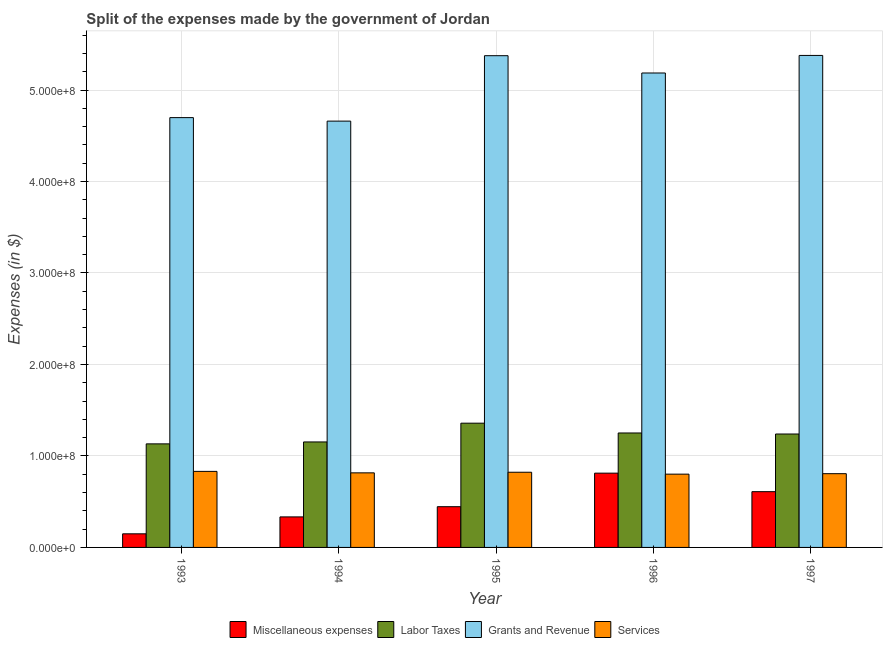Are the number of bars per tick equal to the number of legend labels?
Your answer should be very brief. Yes. What is the label of the 1st group of bars from the left?
Ensure brevity in your answer.  1993. What is the amount spent on labor taxes in 1995?
Make the answer very short. 1.36e+08. Across all years, what is the maximum amount spent on services?
Offer a very short reply. 8.31e+07. Across all years, what is the minimum amount spent on services?
Make the answer very short. 8.01e+07. In which year was the amount spent on services maximum?
Provide a short and direct response. 1993. In which year was the amount spent on miscellaneous expenses minimum?
Provide a succinct answer. 1993. What is the total amount spent on miscellaneous expenses in the graph?
Offer a terse response. 2.35e+08. What is the difference between the amount spent on miscellaneous expenses in 1995 and that in 1997?
Make the answer very short. -1.64e+07. What is the difference between the amount spent on labor taxes in 1997 and the amount spent on services in 1996?
Offer a very short reply. -1.13e+06. What is the average amount spent on grants and revenue per year?
Provide a short and direct response. 5.06e+08. In the year 1997, what is the difference between the amount spent on services and amount spent on miscellaneous expenses?
Offer a very short reply. 0. In how many years, is the amount spent on services greater than 440000000 $?
Offer a terse response. 0. What is the ratio of the amount spent on miscellaneous expenses in 1993 to that in 1995?
Your response must be concise. 0.33. What is the difference between the highest and the second highest amount spent on miscellaneous expenses?
Offer a very short reply. 2.02e+07. What is the difference between the highest and the lowest amount spent on services?
Keep it short and to the point. 3.02e+06. Is the sum of the amount spent on miscellaneous expenses in 1994 and 1997 greater than the maximum amount spent on grants and revenue across all years?
Your answer should be very brief. Yes. Is it the case that in every year, the sum of the amount spent on labor taxes and amount spent on grants and revenue is greater than the sum of amount spent on services and amount spent on miscellaneous expenses?
Ensure brevity in your answer.  No. What does the 2nd bar from the left in 1997 represents?
Make the answer very short. Labor Taxes. What does the 1st bar from the right in 1994 represents?
Offer a terse response. Services. Are the values on the major ticks of Y-axis written in scientific E-notation?
Your answer should be compact. Yes. Does the graph contain any zero values?
Ensure brevity in your answer.  No. Does the graph contain grids?
Offer a terse response. Yes. What is the title of the graph?
Give a very brief answer. Split of the expenses made by the government of Jordan. What is the label or title of the X-axis?
Provide a short and direct response. Year. What is the label or title of the Y-axis?
Your answer should be very brief. Expenses (in $). What is the Expenses (in $) of Miscellaneous expenses in 1993?
Make the answer very short. 1.49e+07. What is the Expenses (in $) of Labor Taxes in 1993?
Your answer should be compact. 1.13e+08. What is the Expenses (in $) in Grants and Revenue in 1993?
Offer a terse response. 4.70e+08. What is the Expenses (in $) of Services in 1993?
Your answer should be compact. 8.31e+07. What is the Expenses (in $) in Miscellaneous expenses in 1994?
Provide a succinct answer. 3.34e+07. What is the Expenses (in $) in Labor Taxes in 1994?
Your answer should be compact. 1.15e+08. What is the Expenses (in $) in Grants and Revenue in 1994?
Provide a short and direct response. 4.66e+08. What is the Expenses (in $) of Services in 1994?
Make the answer very short. 8.15e+07. What is the Expenses (in $) in Miscellaneous expenses in 1995?
Your answer should be very brief. 4.45e+07. What is the Expenses (in $) of Labor Taxes in 1995?
Provide a succinct answer. 1.36e+08. What is the Expenses (in $) of Grants and Revenue in 1995?
Make the answer very short. 5.38e+08. What is the Expenses (in $) of Services in 1995?
Your response must be concise. 8.22e+07. What is the Expenses (in $) in Miscellaneous expenses in 1996?
Keep it short and to the point. 8.12e+07. What is the Expenses (in $) of Labor Taxes in 1996?
Your answer should be compact. 1.25e+08. What is the Expenses (in $) of Grants and Revenue in 1996?
Your answer should be compact. 5.19e+08. What is the Expenses (in $) of Services in 1996?
Make the answer very short. 8.01e+07. What is the Expenses (in $) of Miscellaneous expenses in 1997?
Give a very brief answer. 6.10e+07. What is the Expenses (in $) in Labor Taxes in 1997?
Your answer should be very brief. 1.24e+08. What is the Expenses (in $) in Grants and Revenue in 1997?
Your answer should be very brief. 5.38e+08. What is the Expenses (in $) of Services in 1997?
Offer a terse response. 8.06e+07. Across all years, what is the maximum Expenses (in $) of Miscellaneous expenses?
Offer a very short reply. 8.12e+07. Across all years, what is the maximum Expenses (in $) of Labor Taxes?
Offer a very short reply. 1.36e+08. Across all years, what is the maximum Expenses (in $) in Grants and Revenue?
Your answer should be very brief. 5.38e+08. Across all years, what is the maximum Expenses (in $) in Services?
Your answer should be very brief. 8.31e+07. Across all years, what is the minimum Expenses (in $) of Miscellaneous expenses?
Offer a very short reply. 1.49e+07. Across all years, what is the minimum Expenses (in $) in Labor Taxes?
Make the answer very short. 1.13e+08. Across all years, what is the minimum Expenses (in $) in Grants and Revenue?
Your response must be concise. 4.66e+08. Across all years, what is the minimum Expenses (in $) in Services?
Your answer should be very brief. 8.01e+07. What is the total Expenses (in $) in Miscellaneous expenses in the graph?
Your response must be concise. 2.35e+08. What is the total Expenses (in $) in Labor Taxes in the graph?
Provide a succinct answer. 6.13e+08. What is the total Expenses (in $) of Grants and Revenue in the graph?
Offer a very short reply. 2.53e+09. What is the total Expenses (in $) of Services in the graph?
Offer a terse response. 4.08e+08. What is the difference between the Expenses (in $) of Miscellaneous expenses in 1993 and that in 1994?
Keep it short and to the point. -1.85e+07. What is the difference between the Expenses (in $) of Labor Taxes in 1993 and that in 1994?
Offer a very short reply. -2.11e+06. What is the difference between the Expenses (in $) in Grants and Revenue in 1993 and that in 1994?
Keep it short and to the point. 3.83e+06. What is the difference between the Expenses (in $) of Services in 1993 and that in 1994?
Provide a short and direct response. 1.60e+06. What is the difference between the Expenses (in $) of Miscellaneous expenses in 1993 and that in 1995?
Offer a terse response. -2.96e+07. What is the difference between the Expenses (in $) of Labor Taxes in 1993 and that in 1995?
Give a very brief answer. -2.26e+07. What is the difference between the Expenses (in $) in Grants and Revenue in 1993 and that in 1995?
Your answer should be very brief. -6.77e+07. What is the difference between the Expenses (in $) of Services in 1993 and that in 1995?
Keep it short and to the point. 9.30e+05. What is the difference between the Expenses (in $) in Miscellaneous expenses in 1993 and that in 1996?
Keep it short and to the point. -6.63e+07. What is the difference between the Expenses (in $) of Labor Taxes in 1993 and that in 1996?
Provide a short and direct response. -1.19e+07. What is the difference between the Expenses (in $) of Grants and Revenue in 1993 and that in 1996?
Your answer should be compact. -4.88e+07. What is the difference between the Expenses (in $) in Services in 1993 and that in 1996?
Your response must be concise. 3.02e+06. What is the difference between the Expenses (in $) of Miscellaneous expenses in 1993 and that in 1997?
Your answer should be very brief. -4.61e+07. What is the difference between the Expenses (in $) in Labor Taxes in 1993 and that in 1997?
Provide a succinct answer. -1.08e+07. What is the difference between the Expenses (in $) in Grants and Revenue in 1993 and that in 1997?
Provide a succinct answer. -6.80e+07. What is the difference between the Expenses (in $) of Services in 1993 and that in 1997?
Your answer should be compact. 2.50e+06. What is the difference between the Expenses (in $) of Miscellaneous expenses in 1994 and that in 1995?
Your answer should be very brief. -1.12e+07. What is the difference between the Expenses (in $) in Labor Taxes in 1994 and that in 1995?
Offer a terse response. -2.05e+07. What is the difference between the Expenses (in $) of Grants and Revenue in 1994 and that in 1995?
Your answer should be very brief. -7.15e+07. What is the difference between the Expenses (in $) in Services in 1994 and that in 1995?
Ensure brevity in your answer.  -6.70e+05. What is the difference between the Expenses (in $) of Miscellaneous expenses in 1994 and that in 1996?
Offer a terse response. -4.78e+07. What is the difference between the Expenses (in $) in Labor Taxes in 1994 and that in 1996?
Provide a short and direct response. -9.80e+06. What is the difference between the Expenses (in $) in Grants and Revenue in 1994 and that in 1996?
Provide a short and direct response. -5.26e+07. What is the difference between the Expenses (in $) in Services in 1994 and that in 1996?
Offer a terse response. 1.42e+06. What is the difference between the Expenses (in $) in Miscellaneous expenses in 1994 and that in 1997?
Your answer should be compact. -2.76e+07. What is the difference between the Expenses (in $) in Labor Taxes in 1994 and that in 1997?
Your answer should be very brief. -8.67e+06. What is the difference between the Expenses (in $) of Grants and Revenue in 1994 and that in 1997?
Provide a short and direct response. -7.18e+07. What is the difference between the Expenses (in $) in Miscellaneous expenses in 1995 and that in 1996?
Provide a succinct answer. -3.67e+07. What is the difference between the Expenses (in $) of Labor Taxes in 1995 and that in 1996?
Your answer should be very brief. 1.07e+07. What is the difference between the Expenses (in $) in Grants and Revenue in 1995 and that in 1996?
Provide a short and direct response. 1.89e+07. What is the difference between the Expenses (in $) in Services in 1995 and that in 1996?
Ensure brevity in your answer.  2.09e+06. What is the difference between the Expenses (in $) of Miscellaneous expenses in 1995 and that in 1997?
Your response must be concise. -1.64e+07. What is the difference between the Expenses (in $) of Labor Taxes in 1995 and that in 1997?
Your answer should be compact. 1.18e+07. What is the difference between the Expenses (in $) of Services in 1995 and that in 1997?
Ensure brevity in your answer.  1.57e+06. What is the difference between the Expenses (in $) of Miscellaneous expenses in 1996 and that in 1997?
Your response must be concise. 2.02e+07. What is the difference between the Expenses (in $) in Labor Taxes in 1996 and that in 1997?
Keep it short and to the point. 1.13e+06. What is the difference between the Expenses (in $) in Grants and Revenue in 1996 and that in 1997?
Your response must be concise. -1.92e+07. What is the difference between the Expenses (in $) of Services in 1996 and that in 1997?
Offer a terse response. -5.20e+05. What is the difference between the Expenses (in $) in Miscellaneous expenses in 1993 and the Expenses (in $) in Labor Taxes in 1994?
Ensure brevity in your answer.  -1.00e+08. What is the difference between the Expenses (in $) of Miscellaneous expenses in 1993 and the Expenses (in $) of Grants and Revenue in 1994?
Provide a short and direct response. -4.51e+08. What is the difference between the Expenses (in $) in Miscellaneous expenses in 1993 and the Expenses (in $) in Services in 1994?
Offer a terse response. -6.66e+07. What is the difference between the Expenses (in $) in Labor Taxes in 1993 and the Expenses (in $) in Grants and Revenue in 1994?
Provide a succinct answer. -3.53e+08. What is the difference between the Expenses (in $) of Labor Taxes in 1993 and the Expenses (in $) of Services in 1994?
Your response must be concise. 3.17e+07. What is the difference between the Expenses (in $) in Grants and Revenue in 1993 and the Expenses (in $) in Services in 1994?
Provide a succinct answer. 3.88e+08. What is the difference between the Expenses (in $) of Miscellaneous expenses in 1993 and the Expenses (in $) of Labor Taxes in 1995?
Give a very brief answer. -1.21e+08. What is the difference between the Expenses (in $) of Miscellaneous expenses in 1993 and the Expenses (in $) of Grants and Revenue in 1995?
Offer a terse response. -5.23e+08. What is the difference between the Expenses (in $) of Miscellaneous expenses in 1993 and the Expenses (in $) of Services in 1995?
Give a very brief answer. -6.73e+07. What is the difference between the Expenses (in $) of Labor Taxes in 1993 and the Expenses (in $) of Grants and Revenue in 1995?
Offer a very short reply. -4.24e+08. What is the difference between the Expenses (in $) in Labor Taxes in 1993 and the Expenses (in $) in Services in 1995?
Your response must be concise. 3.10e+07. What is the difference between the Expenses (in $) in Grants and Revenue in 1993 and the Expenses (in $) in Services in 1995?
Provide a short and direct response. 3.88e+08. What is the difference between the Expenses (in $) in Miscellaneous expenses in 1993 and the Expenses (in $) in Labor Taxes in 1996?
Keep it short and to the point. -1.10e+08. What is the difference between the Expenses (in $) in Miscellaneous expenses in 1993 and the Expenses (in $) in Grants and Revenue in 1996?
Provide a succinct answer. -5.04e+08. What is the difference between the Expenses (in $) in Miscellaneous expenses in 1993 and the Expenses (in $) in Services in 1996?
Your response must be concise. -6.52e+07. What is the difference between the Expenses (in $) of Labor Taxes in 1993 and the Expenses (in $) of Grants and Revenue in 1996?
Give a very brief answer. -4.05e+08. What is the difference between the Expenses (in $) in Labor Taxes in 1993 and the Expenses (in $) in Services in 1996?
Provide a succinct answer. 3.31e+07. What is the difference between the Expenses (in $) in Grants and Revenue in 1993 and the Expenses (in $) in Services in 1996?
Provide a short and direct response. 3.90e+08. What is the difference between the Expenses (in $) in Miscellaneous expenses in 1993 and the Expenses (in $) in Labor Taxes in 1997?
Offer a terse response. -1.09e+08. What is the difference between the Expenses (in $) of Miscellaneous expenses in 1993 and the Expenses (in $) of Grants and Revenue in 1997?
Provide a short and direct response. -5.23e+08. What is the difference between the Expenses (in $) of Miscellaneous expenses in 1993 and the Expenses (in $) of Services in 1997?
Give a very brief answer. -6.58e+07. What is the difference between the Expenses (in $) in Labor Taxes in 1993 and the Expenses (in $) in Grants and Revenue in 1997?
Your answer should be very brief. -4.25e+08. What is the difference between the Expenses (in $) in Labor Taxes in 1993 and the Expenses (in $) in Services in 1997?
Your answer should be very brief. 3.26e+07. What is the difference between the Expenses (in $) in Grants and Revenue in 1993 and the Expenses (in $) in Services in 1997?
Provide a succinct answer. 3.89e+08. What is the difference between the Expenses (in $) of Miscellaneous expenses in 1994 and the Expenses (in $) of Labor Taxes in 1995?
Ensure brevity in your answer.  -1.02e+08. What is the difference between the Expenses (in $) of Miscellaneous expenses in 1994 and the Expenses (in $) of Grants and Revenue in 1995?
Your response must be concise. -5.04e+08. What is the difference between the Expenses (in $) of Miscellaneous expenses in 1994 and the Expenses (in $) of Services in 1995?
Keep it short and to the point. -4.88e+07. What is the difference between the Expenses (in $) in Labor Taxes in 1994 and the Expenses (in $) in Grants and Revenue in 1995?
Offer a terse response. -4.22e+08. What is the difference between the Expenses (in $) of Labor Taxes in 1994 and the Expenses (in $) of Services in 1995?
Keep it short and to the point. 3.31e+07. What is the difference between the Expenses (in $) in Grants and Revenue in 1994 and the Expenses (in $) in Services in 1995?
Keep it short and to the point. 3.84e+08. What is the difference between the Expenses (in $) of Miscellaneous expenses in 1994 and the Expenses (in $) of Labor Taxes in 1996?
Make the answer very short. -9.17e+07. What is the difference between the Expenses (in $) of Miscellaneous expenses in 1994 and the Expenses (in $) of Grants and Revenue in 1996?
Your answer should be compact. -4.85e+08. What is the difference between the Expenses (in $) in Miscellaneous expenses in 1994 and the Expenses (in $) in Services in 1996?
Your answer should be very brief. -4.67e+07. What is the difference between the Expenses (in $) of Labor Taxes in 1994 and the Expenses (in $) of Grants and Revenue in 1996?
Give a very brief answer. -4.03e+08. What is the difference between the Expenses (in $) in Labor Taxes in 1994 and the Expenses (in $) in Services in 1996?
Make the answer very short. 3.52e+07. What is the difference between the Expenses (in $) in Grants and Revenue in 1994 and the Expenses (in $) in Services in 1996?
Provide a succinct answer. 3.86e+08. What is the difference between the Expenses (in $) in Miscellaneous expenses in 1994 and the Expenses (in $) in Labor Taxes in 1997?
Your response must be concise. -9.06e+07. What is the difference between the Expenses (in $) of Miscellaneous expenses in 1994 and the Expenses (in $) of Grants and Revenue in 1997?
Keep it short and to the point. -5.04e+08. What is the difference between the Expenses (in $) of Miscellaneous expenses in 1994 and the Expenses (in $) of Services in 1997?
Give a very brief answer. -4.72e+07. What is the difference between the Expenses (in $) of Labor Taxes in 1994 and the Expenses (in $) of Grants and Revenue in 1997?
Offer a very short reply. -4.23e+08. What is the difference between the Expenses (in $) of Labor Taxes in 1994 and the Expenses (in $) of Services in 1997?
Make the answer very short. 3.47e+07. What is the difference between the Expenses (in $) in Grants and Revenue in 1994 and the Expenses (in $) in Services in 1997?
Offer a very short reply. 3.85e+08. What is the difference between the Expenses (in $) of Miscellaneous expenses in 1995 and the Expenses (in $) of Labor Taxes in 1996?
Provide a succinct answer. -8.06e+07. What is the difference between the Expenses (in $) of Miscellaneous expenses in 1995 and the Expenses (in $) of Grants and Revenue in 1996?
Ensure brevity in your answer.  -4.74e+08. What is the difference between the Expenses (in $) in Miscellaneous expenses in 1995 and the Expenses (in $) in Services in 1996?
Make the answer very short. -3.56e+07. What is the difference between the Expenses (in $) of Labor Taxes in 1995 and the Expenses (in $) of Grants and Revenue in 1996?
Your answer should be very brief. -3.83e+08. What is the difference between the Expenses (in $) in Labor Taxes in 1995 and the Expenses (in $) in Services in 1996?
Your response must be concise. 5.57e+07. What is the difference between the Expenses (in $) of Grants and Revenue in 1995 and the Expenses (in $) of Services in 1996?
Ensure brevity in your answer.  4.57e+08. What is the difference between the Expenses (in $) of Miscellaneous expenses in 1995 and the Expenses (in $) of Labor Taxes in 1997?
Make the answer very short. -7.95e+07. What is the difference between the Expenses (in $) of Miscellaneous expenses in 1995 and the Expenses (in $) of Grants and Revenue in 1997?
Your answer should be compact. -4.93e+08. What is the difference between the Expenses (in $) in Miscellaneous expenses in 1995 and the Expenses (in $) in Services in 1997?
Your answer should be compact. -3.61e+07. What is the difference between the Expenses (in $) of Labor Taxes in 1995 and the Expenses (in $) of Grants and Revenue in 1997?
Your answer should be compact. -4.02e+08. What is the difference between the Expenses (in $) of Labor Taxes in 1995 and the Expenses (in $) of Services in 1997?
Offer a terse response. 5.52e+07. What is the difference between the Expenses (in $) of Grants and Revenue in 1995 and the Expenses (in $) of Services in 1997?
Your answer should be compact. 4.57e+08. What is the difference between the Expenses (in $) in Miscellaneous expenses in 1996 and the Expenses (in $) in Labor Taxes in 1997?
Your answer should be very brief. -4.28e+07. What is the difference between the Expenses (in $) in Miscellaneous expenses in 1996 and the Expenses (in $) in Grants and Revenue in 1997?
Provide a short and direct response. -4.57e+08. What is the difference between the Expenses (in $) in Miscellaneous expenses in 1996 and the Expenses (in $) in Services in 1997?
Make the answer very short. 5.80e+05. What is the difference between the Expenses (in $) in Labor Taxes in 1996 and the Expenses (in $) in Grants and Revenue in 1997?
Ensure brevity in your answer.  -4.13e+08. What is the difference between the Expenses (in $) of Labor Taxes in 1996 and the Expenses (in $) of Services in 1997?
Your answer should be compact. 4.45e+07. What is the difference between the Expenses (in $) of Grants and Revenue in 1996 and the Expenses (in $) of Services in 1997?
Ensure brevity in your answer.  4.38e+08. What is the average Expenses (in $) of Miscellaneous expenses per year?
Offer a very short reply. 4.70e+07. What is the average Expenses (in $) of Labor Taxes per year?
Your response must be concise. 1.23e+08. What is the average Expenses (in $) of Grants and Revenue per year?
Offer a terse response. 5.06e+08. What is the average Expenses (in $) in Services per year?
Your answer should be very brief. 8.15e+07. In the year 1993, what is the difference between the Expenses (in $) in Miscellaneous expenses and Expenses (in $) in Labor Taxes?
Give a very brief answer. -9.83e+07. In the year 1993, what is the difference between the Expenses (in $) of Miscellaneous expenses and Expenses (in $) of Grants and Revenue?
Your answer should be very brief. -4.55e+08. In the year 1993, what is the difference between the Expenses (in $) in Miscellaneous expenses and Expenses (in $) in Services?
Provide a short and direct response. -6.82e+07. In the year 1993, what is the difference between the Expenses (in $) in Labor Taxes and Expenses (in $) in Grants and Revenue?
Your response must be concise. -3.57e+08. In the year 1993, what is the difference between the Expenses (in $) in Labor Taxes and Expenses (in $) in Services?
Give a very brief answer. 3.01e+07. In the year 1993, what is the difference between the Expenses (in $) in Grants and Revenue and Expenses (in $) in Services?
Provide a succinct answer. 3.87e+08. In the year 1994, what is the difference between the Expenses (in $) in Miscellaneous expenses and Expenses (in $) in Labor Taxes?
Offer a very short reply. -8.19e+07. In the year 1994, what is the difference between the Expenses (in $) in Miscellaneous expenses and Expenses (in $) in Grants and Revenue?
Your answer should be compact. -4.33e+08. In the year 1994, what is the difference between the Expenses (in $) of Miscellaneous expenses and Expenses (in $) of Services?
Give a very brief answer. -4.82e+07. In the year 1994, what is the difference between the Expenses (in $) of Labor Taxes and Expenses (in $) of Grants and Revenue?
Provide a short and direct response. -3.51e+08. In the year 1994, what is the difference between the Expenses (in $) in Labor Taxes and Expenses (in $) in Services?
Offer a very short reply. 3.38e+07. In the year 1994, what is the difference between the Expenses (in $) in Grants and Revenue and Expenses (in $) in Services?
Offer a terse response. 3.84e+08. In the year 1995, what is the difference between the Expenses (in $) of Miscellaneous expenses and Expenses (in $) of Labor Taxes?
Your answer should be compact. -9.13e+07. In the year 1995, what is the difference between the Expenses (in $) in Miscellaneous expenses and Expenses (in $) in Grants and Revenue?
Your answer should be compact. -4.93e+08. In the year 1995, what is the difference between the Expenses (in $) in Miscellaneous expenses and Expenses (in $) in Services?
Your answer should be compact. -3.77e+07. In the year 1995, what is the difference between the Expenses (in $) of Labor Taxes and Expenses (in $) of Grants and Revenue?
Ensure brevity in your answer.  -4.02e+08. In the year 1995, what is the difference between the Expenses (in $) in Labor Taxes and Expenses (in $) in Services?
Offer a terse response. 5.36e+07. In the year 1995, what is the difference between the Expenses (in $) in Grants and Revenue and Expenses (in $) in Services?
Your answer should be very brief. 4.55e+08. In the year 1996, what is the difference between the Expenses (in $) of Miscellaneous expenses and Expenses (in $) of Labor Taxes?
Make the answer very short. -4.39e+07. In the year 1996, what is the difference between the Expenses (in $) of Miscellaneous expenses and Expenses (in $) of Grants and Revenue?
Ensure brevity in your answer.  -4.37e+08. In the year 1996, what is the difference between the Expenses (in $) of Miscellaneous expenses and Expenses (in $) of Services?
Give a very brief answer. 1.10e+06. In the year 1996, what is the difference between the Expenses (in $) in Labor Taxes and Expenses (in $) in Grants and Revenue?
Ensure brevity in your answer.  -3.94e+08. In the year 1996, what is the difference between the Expenses (in $) of Labor Taxes and Expenses (in $) of Services?
Offer a very short reply. 4.50e+07. In the year 1996, what is the difference between the Expenses (in $) of Grants and Revenue and Expenses (in $) of Services?
Provide a short and direct response. 4.39e+08. In the year 1997, what is the difference between the Expenses (in $) in Miscellaneous expenses and Expenses (in $) in Labor Taxes?
Provide a short and direct response. -6.30e+07. In the year 1997, what is the difference between the Expenses (in $) in Miscellaneous expenses and Expenses (in $) in Grants and Revenue?
Provide a succinct answer. -4.77e+08. In the year 1997, what is the difference between the Expenses (in $) of Miscellaneous expenses and Expenses (in $) of Services?
Ensure brevity in your answer.  -1.97e+07. In the year 1997, what is the difference between the Expenses (in $) in Labor Taxes and Expenses (in $) in Grants and Revenue?
Your response must be concise. -4.14e+08. In the year 1997, what is the difference between the Expenses (in $) in Labor Taxes and Expenses (in $) in Services?
Provide a short and direct response. 4.34e+07. In the year 1997, what is the difference between the Expenses (in $) in Grants and Revenue and Expenses (in $) in Services?
Your response must be concise. 4.57e+08. What is the ratio of the Expenses (in $) of Miscellaneous expenses in 1993 to that in 1994?
Give a very brief answer. 0.45. What is the ratio of the Expenses (in $) of Labor Taxes in 1993 to that in 1994?
Your answer should be compact. 0.98. What is the ratio of the Expenses (in $) of Grants and Revenue in 1993 to that in 1994?
Provide a short and direct response. 1.01. What is the ratio of the Expenses (in $) of Services in 1993 to that in 1994?
Your answer should be very brief. 1.02. What is the ratio of the Expenses (in $) in Miscellaneous expenses in 1993 to that in 1995?
Offer a terse response. 0.33. What is the ratio of the Expenses (in $) in Labor Taxes in 1993 to that in 1995?
Your answer should be compact. 0.83. What is the ratio of the Expenses (in $) of Grants and Revenue in 1993 to that in 1995?
Offer a very short reply. 0.87. What is the ratio of the Expenses (in $) in Services in 1993 to that in 1995?
Provide a short and direct response. 1.01. What is the ratio of the Expenses (in $) of Miscellaneous expenses in 1993 to that in 1996?
Offer a terse response. 0.18. What is the ratio of the Expenses (in $) of Labor Taxes in 1993 to that in 1996?
Offer a very short reply. 0.9. What is the ratio of the Expenses (in $) in Grants and Revenue in 1993 to that in 1996?
Offer a very short reply. 0.91. What is the ratio of the Expenses (in $) of Services in 1993 to that in 1996?
Offer a very short reply. 1.04. What is the ratio of the Expenses (in $) of Miscellaneous expenses in 1993 to that in 1997?
Provide a succinct answer. 0.24. What is the ratio of the Expenses (in $) of Labor Taxes in 1993 to that in 1997?
Your response must be concise. 0.91. What is the ratio of the Expenses (in $) of Grants and Revenue in 1993 to that in 1997?
Your answer should be very brief. 0.87. What is the ratio of the Expenses (in $) in Services in 1993 to that in 1997?
Keep it short and to the point. 1.03. What is the ratio of the Expenses (in $) of Miscellaneous expenses in 1994 to that in 1995?
Provide a short and direct response. 0.75. What is the ratio of the Expenses (in $) in Labor Taxes in 1994 to that in 1995?
Your response must be concise. 0.85. What is the ratio of the Expenses (in $) of Grants and Revenue in 1994 to that in 1995?
Your response must be concise. 0.87. What is the ratio of the Expenses (in $) in Services in 1994 to that in 1995?
Provide a succinct answer. 0.99. What is the ratio of the Expenses (in $) in Miscellaneous expenses in 1994 to that in 1996?
Your response must be concise. 0.41. What is the ratio of the Expenses (in $) of Labor Taxes in 1994 to that in 1996?
Offer a very short reply. 0.92. What is the ratio of the Expenses (in $) of Grants and Revenue in 1994 to that in 1996?
Provide a short and direct response. 0.9. What is the ratio of the Expenses (in $) of Services in 1994 to that in 1996?
Offer a very short reply. 1.02. What is the ratio of the Expenses (in $) of Miscellaneous expenses in 1994 to that in 1997?
Make the answer very short. 0.55. What is the ratio of the Expenses (in $) in Labor Taxes in 1994 to that in 1997?
Your response must be concise. 0.93. What is the ratio of the Expenses (in $) of Grants and Revenue in 1994 to that in 1997?
Provide a succinct answer. 0.87. What is the ratio of the Expenses (in $) in Services in 1994 to that in 1997?
Offer a terse response. 1.01. What is the ratio of the Expenses (in $) in Miscellaneous expenses in 1995 to that in 1996?
Offer a very short reply. 0.55. What is the ratio of the Expenses (in $) in Labor Taxes in 1995 to that in 1996?
Provide a succinct answer. 1.09. What is the ratio of the Expenses (in $) of Grants and Revenue in 1995 to that in 1996?
Give a very brief answer. 1.04. What is the ratio of the Expenses (in $) in Services in 1995 to that in 1996?
Offer a very short reply. 1.03. What is the ratio of the Expenses (in $) of Miscellaneous expenses in 1995 to that in 1997?
Offer a very short reply. 0.73. What is the ratio of the Expenses (in $) in Labor Taxes in 1995 to that in 1997?
Give a very brief answer. 1.1. What is the ratio of the Expenses (in $) in Grants and Revenue in 1995 to that in 1997?
Offer a very short reply. 1. What is the ratio of the Expenses (in $) in Services in 1995 to that in 1997?
Ensure brevity in your answer.  1.02. What is the ratio of the Expenses (in $) in Miscellaneous expenses in 1996 to that in 1997?
Provide a short and direct response. 1.33. What is the ratio of the Expenses (in $) of Labor Taxes in 1996 to that in 1997?
Provide a succinct answer. 1.01. What is the ratio of the Expenses (in $) in Grants and Revenue in 1996 to that in 1997?
Provide a short and direct response. 0.96. What is the ratio of the Expenses (in $) in Services in 1996 to that in 1997?
Your response must be concise. 0.99. What is the difference between the highest and the second highest Expenses (in $) in Miscellaneous expenses?
Give a very brief answer. 2.02e+07. What is the difference between the highest and the second highest Expenses (in $) in Labor Taxes?
Provide a short and direct response. 1.07e+07. What is the difference between the highest and the second highest Expenses (in $) in Grants and Revenue?
Your answer should be compact. 2.90e+05. What is the difference between the highest and the second highest Expenses (in $) in Services?
Your answer should be very brief. 9.30e+05. What is the difference between the highest and the lowest Expenses (in $) of Miscellaneous expenses?
Provide a short and direct response. 6.63e+07. What is the difference between the highest and the lowest Expenses (in $) of Labor Taxes?
Offer a very short reply. 2.26e+07. What is the difference between the highest and the lowest Expenses (in $) in Grants and Revenue?
Offer a very short reply. 7.18e+07. What is the difference between the highest and the lowest Expenses (in $) in Services?
Offer a very short reply. 3.02e+06. 